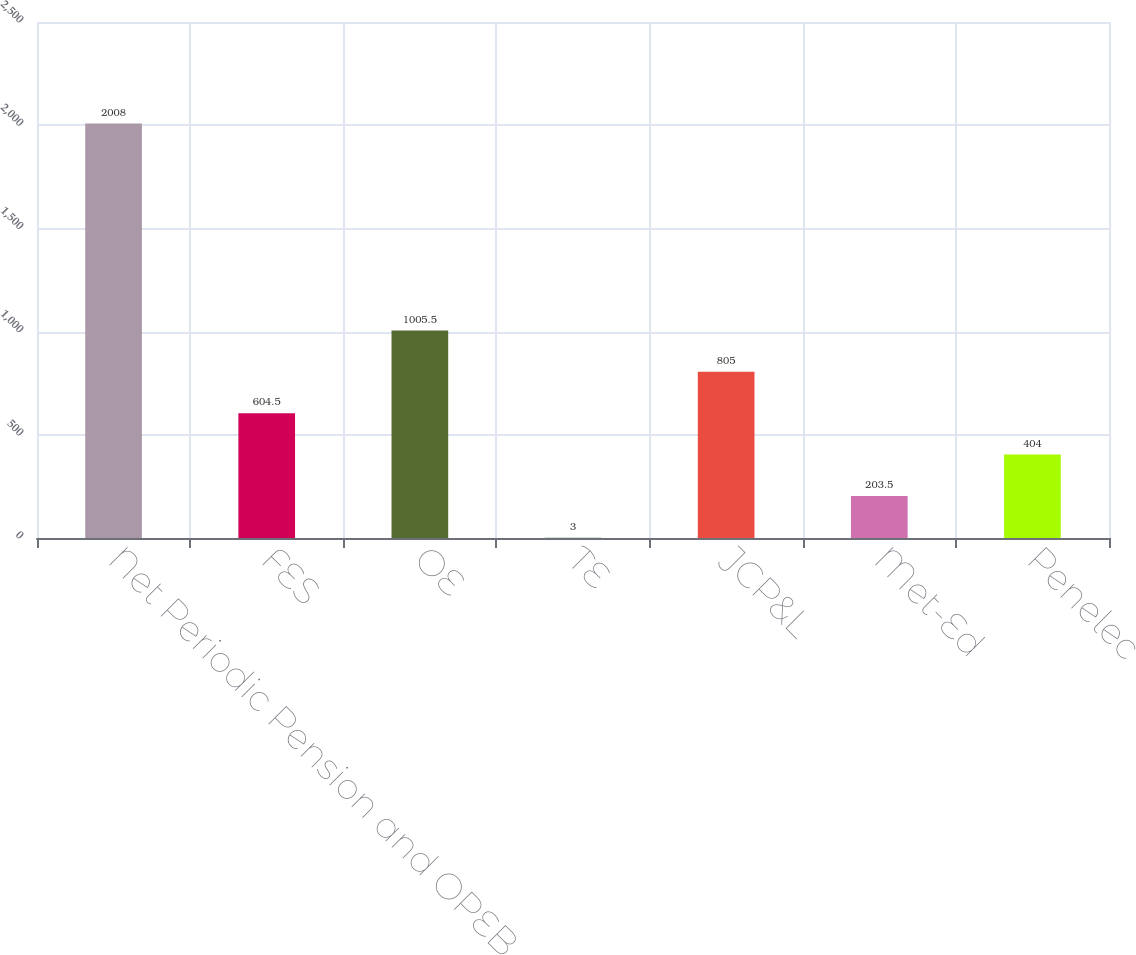Convert chart to OTSL. <chart><loc_0><loc_0><loc_500><loc_500><bar_chart><fcel>Net Periodic Pension and OPEB<fcel>FES<fcel>OE<fcel>TE<fcel>JCP&L<fcel>Met-Ed<fcel>Penelec<nl><fcel>2008<fcel>604.5<fcel>1005.5<fcel>3<fcel>805<fcel>203.5<fcel>404<nl></chart> 